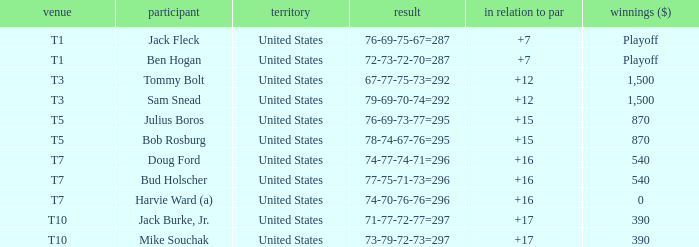Which money has player Jack Fleck with t1 place? Playoff. 